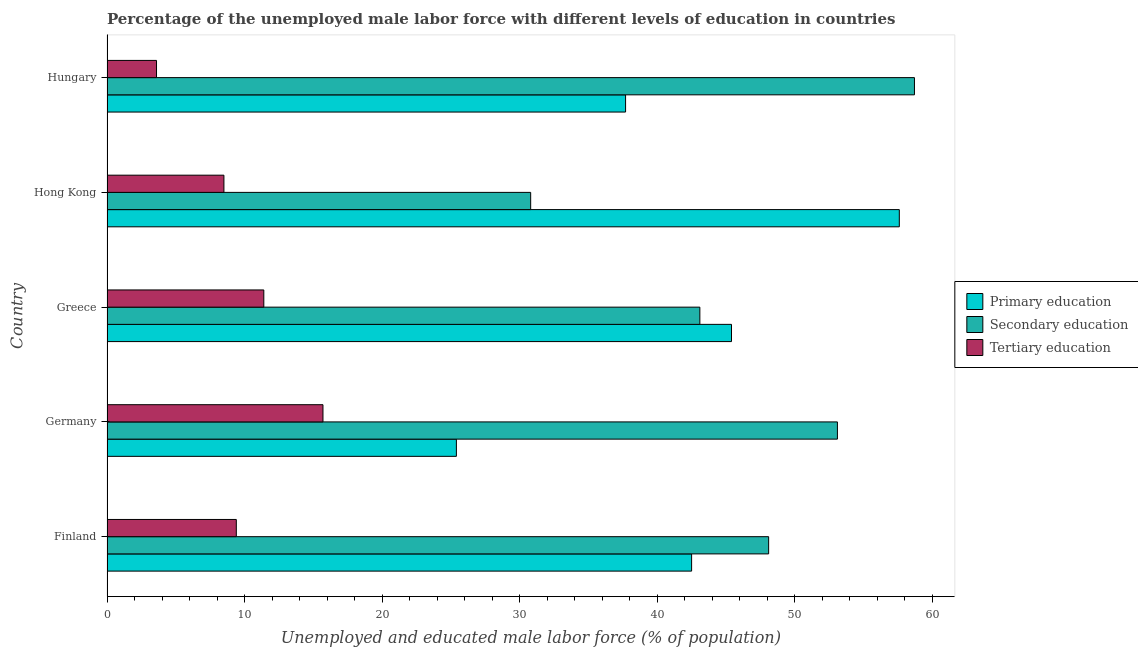How many bars are there on the 4th tick from the top?
Your answer should be compact. 3. What is the percentage of male labor force who received tertiary education in Germany?
Make the answer very short. 15.7. Across all countries, what is the maximum percentage of male labor force who received tertiary education?
Your answer should be very brief. 15.7. Across all countries, what is the minimum percentage of male labor force who received secondary education?
Ensure brevity in your answer.  30.8. In which country was the percentage of male labor force who received secondary education maximum?
Provide a succinct answer. Hungary. In which country was the percentage of male labor force who received tertiary education minimum?
Provide a short and direct response. Hungary. What is the total percentage of male labor force who received tertiary education in the graph?
Offer a terse response. 48.6. What is the difference between the percentage of male labor force who received tertiary education in Hong Kong and that in Hungary?
Your response must be concise. 4.9. What is the difference between the percentage of male labor force who received primary education in Greece and the percentage of male labor force who received tertiary education in Germany?
Keep it short and to the point. 29.7. What is the average percentage of male labor force who received secondary education per country?
Keep it short and to the point. 46.76. What is the difference between the percentage of male labor force who received secondary education and percentage of male labor force who received tertiary education in Greece?
Your answer should be compact. 31.7. What is the ratio of the percentage of male labor force who received secondary education in Greece to that in Hungary?
Make the answer very short. 0.73. What is the difference between the highest and the second highest percentage of male labor force who received primary education?
Provide a succinct answer. 12.2. What is the difference between the highest and the lowest percentage of male labor force who received secondary education?
Your answer should be compact. 27.9. In how many countries, is the percentage of male labor force who received secondary education greater than the average percentage of male labor force who received secondary education taken over all countries?
Provide a succinct answer. 3. What does the 3rd bar from the top in Hungary represents?
Your answer should be compact. Primary education. What does the 2nd bar from the bottom in Hungary represents?
Offer a very short reply. Secondary education. How many bars are there?
Your response must be concise. 15. Are all the bars in the graph horizontal?
Offer a terse response. Yes. What is the difference between two consecutive major ticks on the X-axis?
Make the answer very short. 10. Are the values on the major ticks of X-axis written in scientific E-notation?
Provide a succinct answer. No. Does the graph contain grids?
Offer a terse response. No. Where does the legend appear in the graph?
Provide a short and direct response. Center right. How are the legend labels stacked?
Offer a very short reply. Vertical. What is the title of the graph?
Ensure brevity in your answer.  Percentage of the unemployed male labor force with different levels of education in countries. What is the label or title of the X-axis?
Provide a short and direct response. Unemployed and educated male labor force (% of population). What is the label or title of the Y-axis?
Give a very brief answer. Country. What is the Unemployed and educated male labor force (% of population) of Primary education in Finland?
Give a very brief answer. 42.5. What is the Unemployed and educated male labor force (% of population) of Secondary education in Finland?
Ensure brevity in your answer.  48.1. What is the Unemployed and educated male labor force (% of population) of Tertiary education in Finland?
Ensure brevity in your answer.  9.4. What is the Unemployed and educated male labor force (% of population) in Primary education in Germany?
Give a very brief answer. 25.4. What is the Unemployed and educated male labor force (% of population) of Secondary education in Germany?
Make the answer very short. 53.1. What is the Unemployed and educated male labor force (% of population) of Tertiary education in Germany?
Provide a succinct answer. 15.7. What is the Unemployed and educated male labor force (% of population) of Primary education in Greece?
Provide a short and direct response. 45.4. What is the Unemployed and educated male labor force (% of population) in Secondary education in Greece?
Offer a very short reply. 43.1. What is the Unemployed and educated male labor force (% of population) in Tertiary education in Greece?
Your answer should be compact. 11.4. What is the Unemployed and educated male labor force (% of population) of Primary education in Hong Kong?
Give a very brief answer. 57.6. What is the Unemployed and educated male labor force (% of population) in Secondary education in Hong Kong?
Ensure brevity in your answer.  30.8. What is the Unemployed and educated male labor force (% of population) in Primary education in Hungary?
Give a very brief answer. 37.7. What is the Unemployed and educated male labor force (% of population) of Secondary education in Hungary?
Your answer should be very brief. 58.7. What is the Unemployed and educated male labor force (% of population) in Tertiary education in Hungary?
Keep it short and to the point. 3.6. Across all countries, what is the maximum Unemployed and educated male labor force (% of population) in Primary education?
Give a very brief answer. 57.6. Across all countries, what is the maximum Unemployed and educated male labor force (% of population) in Secondary education?
Keep it short and to the point. 58.7. Across all countries, what is the maximum Unemployed and educated male labor force (% of population) of Tertiary education?
Ensure brevity in your answer.  15.7. Across all countries, what is the minimum Unemployed and educated male labor force (% of population) in Primary education?
Provide a short and direct response. 25.4. Across all countries, what is the minimum Unemployed and educated male labor force (% of population) in Secondary education?
Your answer should be very brief. 30.8. Across all countries, what is the minimum Unemployed and educated male labor force (% of population) in Tertiary education?
Make the answer very short. 3.6. What is the total Unemployed and educated male labor force (% of population) of Primary education in the graph?
Give a very brief answer. 208.6. What is the total Unemployed and educated male labor force (% of population) in Secondary education in the graph?
Provide a short and direct response. 233.8. What is the total Unemployed and educated male labor force (% of population) in Tertiary education in the graph?
Make the answer very short. 48.6. What is the difference between the Unemployed and educated male labor force (% of population) in Secondary education in Finland and that in Germany?
Offer a terse response. -5. What is the difference between the Unemployed and educated male labor force (% of population) in Primary education in Finland and that in Hong Kong?
Your response must be concise. -15.1. What is the difference between the Unemployed and educated male labor force (% of population) of Secondary education in Finland and that in Hong Kong?
Ensure brevity in your answer.  17.3. What is the difference between the Unemployed and educated male labor force (% of population) in Tertiary education in Finland and that in Hong Kong?
Keep it short and to the point. 0.9. What is the difference between the Unemployed and educated male labor force (% of population) in Primary education in Finland and that in Hungary?
Offer a terse response. 4.8. What is the difference between the Unemployed and educated male labor force (% of population) in Primary education in Germany and that in Greece?
Your answer should be compact. -20. What is the difference between the Unemployed and educated male labor force (% of population) in Secondary education in Germany and that in Greece?
Offer a very short reply. 10. What is the difference between the Unemployed and educated male labor force (% of population) of Tertiary education in Germany and that in Greece?
Provide a short and direct response. 4.3. What is the difference between the Unemployed and educated male labor force (% of population) in Primary education in Germany and that in Hong Kong?
Your answer should be compact. -32.2. What is the difference between the Unemployed and educated male labor force (% of population) of Secondary education in Germany and that in Hong Kong?
Your response must be concise. 22.3. What is the difference between the Unemployed and educated male labor force (% of population) in Primary education in Germany and that in Hungary?
Offer a very short reply. -12.3. What is the difference between the Unemployed and educated male labor force (% of population) of Primary education in Greece and that in Hong Kong?
Give a very brief answer. -12.2. What is the difference between the Unemployed and educated male labor force (% of population) of Primary education in Greece and that in Hungary?
Offer a terse response. 7.7. What is the difference between the Unemployed and educated male labor force (% of population) in Secondary education in Greece and that in Hungary?
Offer a very short reply. -15.6. What is the difference between the Unemployed and educated male labor force (% of population) of Tertiary education in Greece and that in Hungary?
Your answer should be very brief. 7.8. What is the difference between the Unemployed and educated male labor force (% of population) of Primary education in Hong Kong and that in Hungary?
Offer a very short reply. 19.9. What is the difference between the Unemployed and educated male labor force (% of population) in Secondary education in Hong Kong and that in Hungary?
Provide a succinct answer. -27.9. What is the difference between the Unemployed and educated male labor force (% of population) in Tertiary education in Hong Kong and that in Hungary?
Provide a succinct answer. 4.9. What is the difference between the Unemployed and educated male labor force (% of population) in Primary education in Finland and the Unemployed and educated male labor force (% of population) in Secondary education in Germany?
Your answer should be very brief. -10.6. What is the difference between the Unemployed and educated male labor force (% of population) in Primary education in Finland and the Unemployed and educated male labor force (% of population) in Tertiary education in Germany?
Your response must be concise. 26.8. What is the difference between the Unemployed and educated male labor force (% of population) in Secondary education in Finland and the Unemployed and educated male labor force (% of population) in Tertiary education in Germany?
Offer a very short reply. 32.4. What is the difference between the Unemployed and educated male labor force (% of population) of Primary education in Finland and the Unemployed and educated male labor force (% of population) of Secondary education in Greece?
Ensure brevity in your answer.  -0.6. What is the difference between the Unemployed and educated male labor force (% of population) in Primary education in Finland and the Unemployed and educated male labor force (% of population) in Tertiary education in Greece?
Make the answer very short. 31.1. What is the difference between the Unemployed and educated male labor force (% of population) in Secondary education in Finland and the Unemployed and educated male labor force (% of population) in Tertiary education in Greece?
Your answer should be compact. 36.7. What is the difference between the Unemployed and educated male labor force (% of population) of Primary education in Finland and the Unemployed and educated male labor force (% of population) of Secondary education in Hong Kong?
Ensure brevity in your answer.  11.7. What is the difference between the Unemployed and educated male labor force (% of population) of Primary education in Finland and the Unemployed and educated male labor force (% of population) of Tertiary education in Hong Kong?
Your answer should be very brief. 34. What is the difference between the Unemployed and educated male labor force (% of population) of Secondary education in Finland and the Unemployed and educated male labor force (% of population) of Tertiary education in Hong Kong?
Provide a succinct answer. 39.6. What is the difference between the Unemployed and educated male labor force (% of population) in Primary education in Finland and the Unemployed and educated male labor force (% of population) in Secondary education in Hungary?
Keep it short and to the point. -16.2. What is the difference between the Unemployed and educated male labor force (% of population) of Primary education in Finland and the Unemployed and educated male labor force (% of population) of Tertiary education in Hungary?
Ensure brevity in your answer.  38.9. What is the difference between the Unemployed and educated male labor force (% of population) of Secondary education in Finland and the Unemployed and educated male labor force (% of population) of Tertiary education in Hungary?
Keep it short and to the point. 44.5. What is the difference between the Unemployed and educated male labor force (% of population) of Primary education in Germany and the Unemployed and educated male labor force (% of population) of Secondary education in Greece?
Offer a very short reply. -17.7. What is the difference between the Unemployed and educated male labor force (% of population) of Secondary education in Germany and the Unemployed and educated male labor force (% of population) of Tertiary education in Greece?
Ensure brevity in your answer.  41.7. What is the difference between the Unemployed and educated male labor force (% of population) of Primary education in Germany and the Unemployed and educated male labor force (% of population) of Secondary education in Hong Kong?
Give a very brief answer. -5.4. What is the difference between the Unemployed and educated male labor force (% of population) in Secondary education in Germany and the Unemployed and educated male labor force (% of population) in Tertiary education in Hong Kong?
Offer a terse response. 44.6. What is the difference between the Unemployed and educated male labor force (% of population) of Primary education in Germany and the Unemployed and educated male labor force (% of population) of Secondary education in Hungary?
Offer a very short reply. -33.3. What is the difference between the Unemployed and educated male labor force (% of population) of Primary education in Germany and the Unemployed and educated male labor force (% of population) of Tertiary education in Hungary?
Keep it short and to the point. 21.8. What is the difference between the Unemployed and educated male labor force (% of population) in Secondary education in Germany and the Unemployed and educated male labor force (% of population) in Tertiary education in Hungary?
Your answer should be very brief. 49.5. What is the difference between the Unemployed and educated male labor force (% of population) in Primary education in Greece and the Unemployed and educated male labor force (% of population) in Tertiary education in Hong Kong?
Ensure brevity in your answer.  36.9. What is the difference between the Unemployed and educated male labor force (% of population) of Secondary education in Greece and the Unemployed and educated male labor force (% of population) of Tertiary education in Hong Kong?
Give a very brief answer. 34.6. What is the difference between the Unemployed and educated male labor force (% of population) of Primary education in Greece and the Unemployed and educated male labor force (% of population) of Tertiary education in Hungary?
Give a very brief answer. 41.8. What is the difference between the Unemployed and educated male labor force (% of population) in Secondary education in Greece and the Unemployed and educated male labor force (% of population) in Tertiary education in Hungary?
Make the answer very short. 39.5. What is the difference between the Unemployed and educated male labor force (% of population) in Secondary education in Hong Kong and the Unemployed and educated male labor force (% of population) in Tertiary education in Hungary?
Your response must be concise. 27.2. What is the average Unemployed and educated male labor force (% of population) in Primary education per country?
Ensure brevity in your answer.  41.72. What is the average Unemployed and educated male labor force (% of population) of Secondary education per country?
Ensure brevity in your answer.  46.76. What is the average Unemployed and educated male labor force (% of population) in Tertiary education per country?
Offer a very short reply. 9.72. What is the difference between the Unemployed and educated male labor force (% of population) in Primary education and Unemployed and educated male labor force (% of population) in Secondary education in Finland?
Provide a short and direct response. -5.6. What is the difference between the Unemployed and educated male labor force (% of population) in Primary education and Unemployed and educated male labor force (% of population) in Tertiary education in Finland?
Keep it short and to the point. 33.1. What is the difference between the Unemployed and educated male labor force (% of population) of Secondary education and Unemployed and educated male labor force (% of population) of Tertiary education in Finland?
Provide a short and direct response. 38.7. What is the difference between the Unemployed and educated male labor force (% of population) in Primary education and Unemployed and educated male labor force (% of population) in Secondary education in Germany?
Ensure brevity in your answer.  -27.7. What is the difference between the Unemployed and educated male labor force (% of population) in Secondary education and Unemployed and educated male labor force (% of population) in Tertiary education in Germany?
Provide a short and direct response. 37.4. What is the difference between the Unemployed and educated male labor force (% of population) in Secondary education and Unemployed and educated male labor force (% of population) in Tertiary education in Greece?
Your response must be concise. 31.7. What is the difference between the Unemployed and educated male labor force (% of population) in Primary education and Unemployed and educated male labor force (% of population) in Secondary education in Hong Kong?
Make the answer very short. 26.8. What is the difference between the Unemployed and educated male labor force (% of population) in Primary education and Unemployed and educated male labor force (% of population) in Tertiary education in Hong Kong?
Your response must be concise. 49.1. What is the difference between the Unemployed and educated male labor force (% of population) in Secondary education and Unemployed and educated male labor force (% of population) in Tertiary education in Hong Kong?
Keep it short and to the point. 22.3. What is the difference between the Unemployed and educated male labor force (% of population) in Primary education and Unemployed and educated male labor force (% of population) in Secondary education in Hungary?
Your answer should be very brief. -21. What is the difference between the Unemployed and educated male labor force (% of population) in Primary education and Unemployed and educated male labor force (% of population) in Tertiary education in Hungary?
Make the answer very short. 34.1. What is the difference between the Unemployed and educated male labor force (% of population) of Secondary education and Unemployed and educated male labor force (% of population) of Tertiary education in Hungary?
Offer a terse response. 55.1. What is the ratio of the Unemployed and educated male labor force (% of population) in Primary education in Finland to that in Germany?
Offer a very short reply. 1.67. What is the ratio of the Unemployed and educated male labor force (% of population) of Secondary education in Finland to that in Germany?
Offer a very short reply. 0.91. What is the ratio of the Unemployed and educated male labor force (% of population) of Tertiary education in Finland to that in Germany?
Your response must be concise. 0.6. What is the ratio of the Unemployed and educated male labor force (% of population) of Primary education in Finland to that in Greece?
Keep it short and to the point. 0.94. What is the ratio of the Unemployed and educated male labor force (% of population) in Secondary education in Finland to that in Greece?
Provide a short and direct response. 1.12. What is the ratio of the Unemployed and educated male labor force (% of population) in Tertiary education in Finland to that in Greece?
Make the answer very short. 0.82. What is the ratio of the Unemployed and educated male labor force (% of population) in Primary education in Finland to that in Hong Kong?
Provide a short and direct response. 0.74. What is the ratio of the Unemployed and educated male labor force (% of population) in Secondary education in Finland to that in Hong Kong?
Your answer should be very brief. 1.56. What is the ratio of the Unemployed and educated male labor force (% of population) in Tertiary education in Finland to that in Hong Kong?
Your answer should be compact. 1.11. What is the ratio of the Unemployed and educated male labor force (% of population) of Primary education in Finland to that in Hungary?
Ensure brevity in your answer.  1.13. What is the ratio of the Unemployed and educated male labor force (% of population) in Secondary education in Finland to that in Hungary?
Make the answer very short. 0.82. What is the ratio of the Unemployed and educated male labor force (% of population) of Tertiary education in Finland to that in Hungary?
Provide a succinct answer. 2.61. What is the ratio of the Unemployed and educated male labor force (% of population) of Primary education in Germany to that in Greece?
Your response must be concise. 0.56. What is the ratio of the Unemployed and educated male labor force (% of population) of Secondary education in Germany to that in Greece?
Offer a very short reply. 1.23. What is the ratio of the Unemployed and educated male labor force (% of population) in Tertiary education in Germany to that in Greece?
Ensure brevity in your answer.  1.38. What is the ratio of the Unemployed and educated male labor force (% of population) of Primary education in Germany to that in Hong Kong?
Offer a terse response. 0.44. What is the ratio of the Unemployed and educated male labor force (% of population) in Secondary education in Germany to that in Hong Kong?
Provide a succinct answer. 1.72. What is the ratio of the Unemployed and educated male labor force (% of population) in Tertiary education in Germany to that in Hong Kong?
Offer a very short reply. 1.85. What is the ratio of the Unemployed and educated male labor force (% of population) of Primary education in Germany to that in Hungary?
Offer a terse response. 0.67. What is the ratio of the Unemployed and educated male labor force (% of population) of Secondary education in Germany to that in Hungary?
Offer a very short reply. 0.9. What is the ratio of the Unemployed and educated male labor force (% of population) of Tertiary education in Germany to that in Hungary?
Provide a succinct answer. 4.36. What is the ratio of the Unemployed and educated male labor force (% of population) of Primary education in Greece to that in Hong Kong?
Give a very brief answer. 0.79. What is the ratio of the Unemployed and educated male labor force (% of population) of Secondary education in Greece to that in Hong Kong?
Provide a short and direct response. 1.4. What is the ratio of the Unemployed and educated male labor force (% of population) of Tertiary education in Greece to that in Hong Kong?
Provide a short and direct response. 1.34. What is the ratio of the Unemployed and educated male labor force (% of population) in Primary education in Greece to that in Hungary?
Make the answer very short. 1.2. What is the ratio of the Unemployed and educated male labor force (% of population) of Secondary education in Greece to that in Hungary?
Give a very brief answer. 0.73. What is the ratio of the Unemployed and educated male labor force (% of population) of Tertiary education in Greece to that in Hungary?
Keep it short and to the point. 3.17. What is the ratio of the Unemployed and educated male labor force (% of population) of Primary education in Hong Kong to that in Hungary?
Provide a short and direct response. 1.53. What is the ratio of the Unemployed and educated male labor force (% of population) in Secondary education in Hong Kong to that in Hungary?
Keep it short and to the point. 0.52. What is the ratio of the Unemployed and educated male labor force (% of population) of Tertiary education in Hong Kong to that in Hungary?
Your response must be concise. 2.36. What is the difference between the highest and the second highest Unemployed and educated male labor force (% of population) of Tertiary education?
Ensure brevity in your answer.  4.3. What is the difference between the highest and the lowest Unemployed and educated male labor force (% of population) of Primary education?
Offer a very short reply. 32.2. What is the difference between the highest and the lowest Unemployed and educated male labor force (% of population) of Secondary education?
Provide a short and direct response. 27.9. 